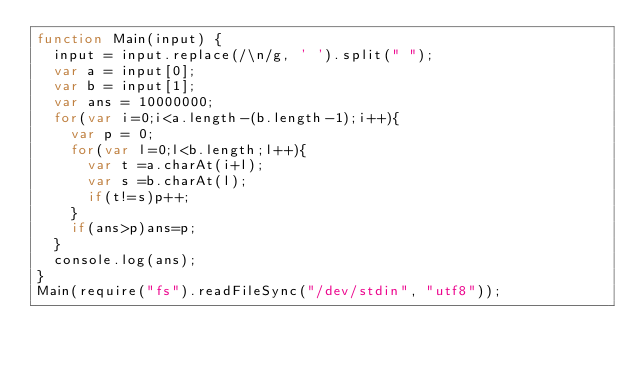Convert code to text. <code><loc_0><loc_0><loc_500><loc_500><_JavaScript_>function Main(input) {
  input = input.replace(/\n/g, ' ').split(" ");
  var a = input[0];
  var b = input[1];
  var ans = 10000000;
  for(var i=0;i<a.length-(b.length-1);i++){
    var p = 0;
    for(var l=0;l<b.length;l++){
      var t =a.charAt(i+l);
      var s =b.charAt(l);
      if(t!=s)p++;
    }
    if(ans>p)ans=p;
  }
  console.log(ans);
}
Main(require("fs").readFileSync("/dev/stdin", "utf8"));
</code> 